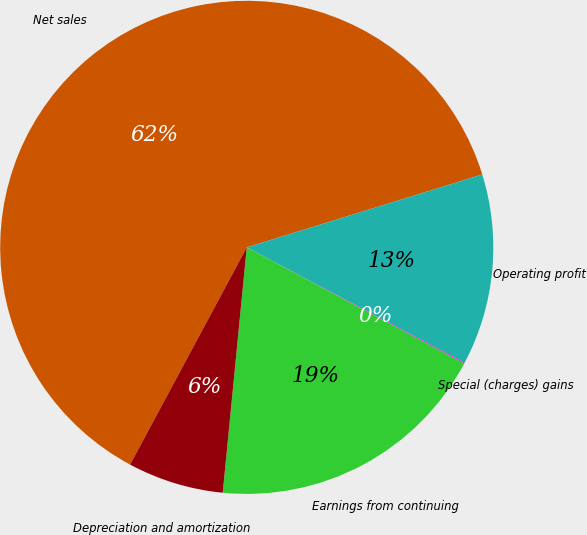Convert chart to OTSL. <chart><loc_0><loc_0><loc_500><loc_500><pie_chart><fcel>Net sales<fcel>Operating profit<fcel>Special (charges) gains<fcel>Earnings from continuing<fcel>Depreciation and amortization<nl><fcel>62.37%<fcel>12.52%<fcel>0.06%<fcel>18.75%<fcel>6.29%<nl></chart> 